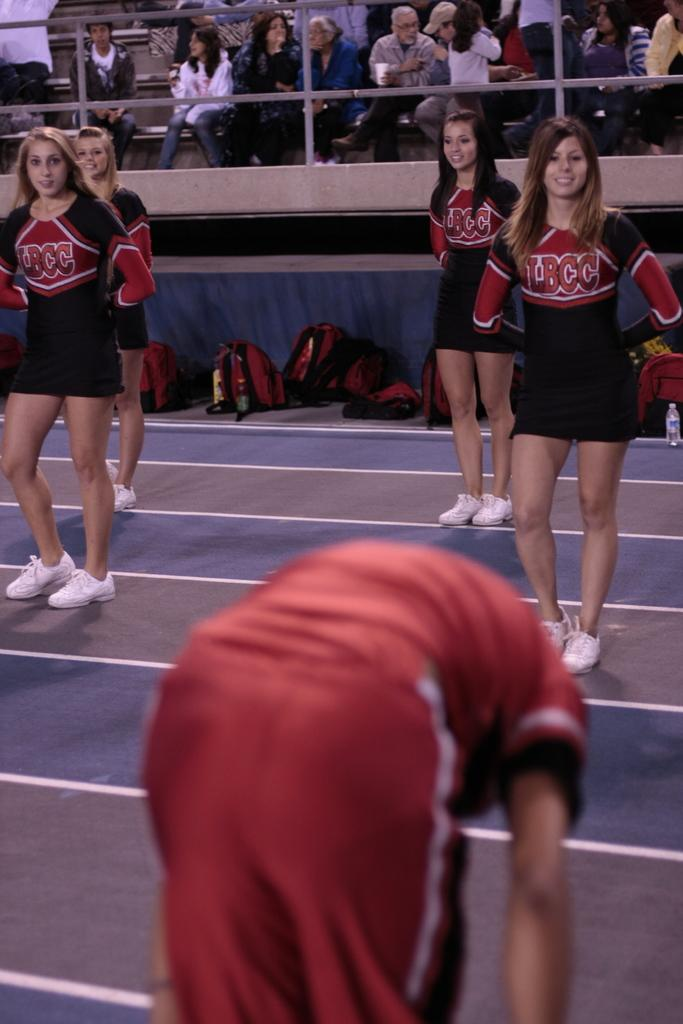<image>
Share a concise interpretation of the image provided. A group of cheerleaders, one is wearing a LBCC outfit 